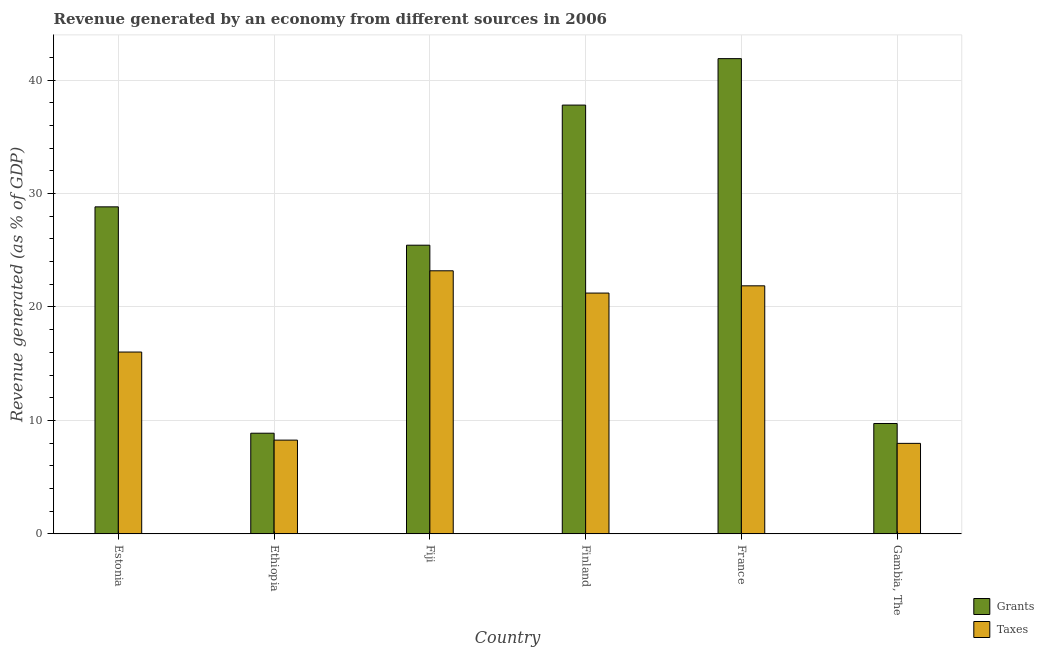How many bars are there on the 5th tick from the left?
Offer a terse response. 2. In how many cases, is the number of bars for a given country not equal to the number of legend labels?
Offer a very short reply. 0. What is the revenue generated by taxes in Ethiopia?
Provide a short and direct response. 8.26. Across all countries, what is the maximum revenue generated by grants?
Offer a terse response. 41.89. Across all countries, what is the minimum revenue generated by taxes?
Your response must be concise. 7.98. In which country was the revenue generated by taxes minimum?
Offer a terse response. Gambia, The. What is the total revenue generated by taxes in the graph?
Ensure brevity in your answer.  98.54. What is the difference between the revenue generated by grants in Ethiopia and that in Finland?
Offer a terse response. -28.92. What is the difference between the revenue generated by taxes in Gambia, The and the revenue generated by grants in France?
Your answer should be very brief. -33.91. What is the average revenue generated by grants per country?
Provide a short and direct response. 25.42. What is the difference between the revenue generated by taxes and revenue generated by grants in Finland?
Make the answer very short. -16.57. What is the ratio of the revenue generated by taxes in Estonia to that in Finland?
Ensure brevity in your answer.  0.76. Is the difference between the revenue generated by taxes in Fiji and Gambia, The greater than the difference between the revenue generated by grants in Fiji and Gambia, The?
Give a very brief answer. No. What is the difference between the highest and the second highest revenue generated by taxes?
Ensure brevity in your answer.  1.32. What is the difference between the highest and the lowest revenue generated by grants?
Your response must be concise. 33.02. In how many countries, is the revenue generated by grants greater than the average revenue generated by grants taken over all countries?
Offer a terse response. 4. Is the sum of the revenue generated by taxes in Ethiopia and Finland greater than the maximum revenue generated by grants across all countries?
Provide a short and direct response. No. What does the 1st bar from the left in Ethiopia represents?
Ensure brevity in your answer.  Grants. What does the 2nd bar from the right in Ethiopia represents?
Provide a succinct answer. Grants. Are all the bars in the graph horizontal?
Provide a short and direct response. No. How many countries are there in the graph?
Offer a terse response. 6. What is the difference between two consecutive major ticks on the Y-axis?
Your answer should be compact. 10. Are the values on the major ticks of Y-axis written in scientific E-notation?
Keep it short and to the point. No. Does the graph contain grids?
Offer a very short reply. Yes. How many legend labels are there?
Give a very brief answer. 2. How are the legend labels stacked?
Offer a very short reply. Vertical. What is the title of the graph?
Offer a terse response. Revenue generated by an economy from different sources in 2006. What is the label or title of the X-axis?
Your response must be concise. Country. What is the label or title of the Y-axis?
Provide a short and direct response. Revenue generated (as % of GDP). What is the Revenue generated (as % of GDP) of Grants in Estonia?
Provide a short and direct response. 28.82. What is the Revenue generated (as % of GDP) in Taxes in Estonia?
Your response must be concise. 16.03. What is the Revenue generated (as % of GDP) in Grants in Ethiopia?
Offer a very short reply. 8.87. What is the Revenue generated (as % of GDP) of Taxes in Ethiopia?
Your response must be concise. 8.26. What is the Revenue generated (as % of GDP) in Grants in Fiji?
Give a very brief answer. 25.44. What is the Revenue generated (as % of GDP) of Taxes in Fiji?
Your answer should be compact. 23.19. What is the Revenue generated (as % of GDP) of Grants in Finland?
Ensure brevity in your answer.  37.79. What is the Revenue generated (as % of GDP) of Taxes in Finland?
Your answer should be compact. 21.22. What is the Revenue generated (as % of GDP) of Grants in France?
Give a very brief answer. 41.89. What is the Revenue generated (as % of GDP) of Taxes in France?
Keep it short and to the point. 21.86. What is the Revenue generated (as % of GDP) in Grants in Gambia, The?
Your answer should be very brief. 9.73. What is the Revenue generated (as % of GDP) in Taxes in Gambia, The?
Offer a very short reply. 7.98. Across all countries, what is the maximum Revenue generated (as % of GDP) in Grants?
Your response must be concise. 41.89. Across all countries, what is the maximum Revenue generated (as % of GDP) in Taxes?
Your answer should be compact. 23.19. Across all countries, what is the minimum Revenue generated (as % of GDP) in Grants?
Ensure brevity in your answer.  8.87. Across all countries, what is the minimum Revenue generated (as % of GDP) of Taxes?
Make the answer very short. 7.98. What is the total Revenue generated (as % of GDP) in Grants in the graph?
Provide a succinct answer. 152.55. What is the total Revenue generated (as % of GDP) in Taxes in the graph?
Ensure brevity in your answer.  98.54. What is the difference between the Revenue generated (as % of GDP) in Grants in Estonia and that in Ethiopia?
Offer a terse response. 19.95. What is the difference between the Revenue generated (as % of GDP) in Taxes in Estonia and that in Ethiopia?
Provide a short and direct response. 7.76. What is the difference between the Revenue generated (as % of GDP) in Grants in Estonia and that in Fiji?
Ensure brevity in your answer.  3.38. What is the difference between the Revenue generated (as % of GDP) in Taxes in Estonia and that in Fiji?
Provide a succinct answer. -7.16. What is the difference between the Revenue generated (as % of GDP) of Grants in Estonia and that in Finland?
Give a very brief answer. -8.97. What is the difference between the Revenue generated (as % of GDP) in Taxes in Estonia and that in Finland?
Your answer should be very brief. -5.2. What is the difference between the Revenue generated (as % of GDP) in Grants in Estonia and that in France?
Make the answer very short. -13.06. What is the difference between the Revenue generated (as % of GDP) of Taxes in Estonia and that in France?
Ensure brevity in your answer.  -5.84. What is the difference between the Revenue generated (as % of GDP) of Grants in Estonia and that in Gambia, The?
Offer a terse response. 19.1. What is the difference between the Revenue generated (as % of GDP) in Taxes in Estonia and that in Gambia, The?
Ensure brevity in your answer.  8.05. What is the difference between the Revenue generated (as % of GDP) of Grants in Ethiopia and that in Fiji?
Offer a terse response. -16.57. What is the difference between the Revenue generated (as % of GDP) of Taxes in Ethiopia and that in Fiji?
Your answer should be compact. -14.92. What is the difference between the Revenue generated (as % of GDP) in Grants in Ethiopia and that in Finland?
Offer a terse response. -28.92. What is the difference between the Revenue generated (as % of GDP) of Taxes in Ethiopia and that in Finland?
Offer a terse response. -12.96. What is the difference between the Revenue generated (as % of GDP) of Grants in Ethiopia and that in France?
Offer a very short reply. -33.02. What is the difference between the Revenue generated (as % of GDP) of Taxes in Ethiopia and that in France?
Keep it short and to the point. -13.6. What is the difference between the Revenue generated (as % of GDP) in Grants in Ethiopia and that in Gambia, The?
Ensure brevity in your answer.  -0.86. What is the difference between the Revenue generated (as % of GDP) in Taxes in Ethiopia and that in Gambia, The?
Give a very brief answer. 0.29. What is the difference between the Revenue generated (as % of GDP) of Grants in Fiji and that in Finland?
Make the answer very short. -12.35. What is the difference between the Revenue generated (as % of GDP) of Taxes in Fiji and that in Finland?
Your answer should be very brief. 1.96. What is the difference between the Revenue generated (as % of GDP) of Grants in Fiji and that in France?
Provide a succinct answer. -16.44. What is the difference between the Revenue generated (as % of GDP) in Taxes in Fiji and that in France?
Your response must be concise. 1.32. What is the difference between the Revenue generated (as % of GDP) in Grants in Fiji and that in Gambia, The?
Keep it short and to the point. 15.72. What is the difference between the Revenue generated (as % of GDP) of Taxes in Fiji and that in Gambia, The?
Make the answer very short. 15.21. What is the difference between the Revenue generated (as % of GDP) of Grants in Finland and that in France?
Your answer should be very brief. -4.09. What is the difference between the Revenue generated (as % of GDP) in Taxes in Finland and that in France?
Your response must be concise. -0.64. What is the difference between the Revenue generated (as % of GDP) in Grants in Finland and that in Gambia, The?
Offer a terse response. 28.06. What is the difference between the Revenue generated (as % of GDP) in Taxes in Finland and that in Gambia, The?
Offer a terse response. 13.25. What is the difference between the Revenue generated (as % of GDP) of Grants in France and that in Gambia, The?
Provide a short and direct response. 32.16. What is the difference between the Revenue generated (as % of GDP) of Taxes in France and that in Gambia, The?
Give a very brief answer. 13.89. What is the difference between the Revenue generated (as % of GDP) in Grants in Estonia and the Revenue generated (as % of GDP) in Taxes in Ethiopia?
Your response must be concise. 20.56. What is the difference between the Revenue generated (as % of GDP) of Grants in Estonia and the Revenue generated (as % of GDP) of Taxes in Fiji?
Offer a terse response. 5.64. What is the difference between the Revenue generated (as % of GDP) of Grants in Estonia and the Revenue generated (as % of GDP) of Taxes in Finland?
Offer a terse response. 7.6. What is the difference between the Revenue generated (as % of GDP) in Grants in Estonia and the Revenue generated (as % of GDP) in Taxes in France?
Make the answer very short. 6.96. What is the difference between the Revenue generated (as % of GDP) of Grants in Estonia and the Revenue generated (as % of GDP) of Taxes in Gambia, The?
Your response must be concise. 20.85. What is the difference between the Revenue generated (as % of GDP) in Grants in Ethiopia and the Revenue generated (as % of GDP) in Taxes in Fiji?
Make the answer very short. -14.32. What is the difference between the Revenue generated (as % of GDP) of Grants in Ethiopia and the Revenue generated (as % of GDP) of Taxes in Finland?
Offer a terse response. -12.35. What is the difference between the Revenue generated (as % of GDP) of Grants in Ethiopia and the Revenue generated (as % of GDP) of Taxes in France?
Your answer should be compact. -12.99. What is the difference between the Revenue generated (as % of GDP) in Grants in Ethiopia and the Revenue generated (as % of GDP) in Taxes in Gambia, The?
Your response must be concise. 0.9. What is the difference between the Revenue generated (as % of GDP) of Grants in Fiji and the Revenue generated (as % of GDP) of Taxes in Finland?
Give a very brief answer. 4.22. What is the difference between the Revenue generated (as % of GDP) in Grants in Fiji and the Revenue generated (as % of GDP) in Taxes in France?
Offer a terse response. 3.58. What is the difference between the Revenue generated (as % of GDP) in Grants in Fiji and the Revenue generated (as % of GDP) in Taxes in Gambia, The?
Offer a terse response. 17.47. What is the difference between the Revenue generated (as % of GDP) of Grants in Finland and the Revenue generated (as % of GDP) of Taxes in France?
Give a very brief answer. 15.93. What is the difference between the Revenue generated (as % of GDP) in Grants in Finland and the Revenue generated (as % of GDP) in Taxes in Gambia, The?
Offer a terse response. 29.82. What is the difference between the Revenue generated (as % of GDP) in Grants in France and the Revenue generated (as % of GDP) in Taxes in Gambia, The?
Keep it short and to the point. 33.91. What is the average Revenue generated (as % of GDP) of Grants per country?
Ensure brevity in your answer.  25.42. What is the average Revenue generated (as % of GDP) of Taxes per country?
Your answer should be compact. 16.42. What is the difference between the Revenue generated (as % of GDP) of Grants and Revenue generated (as % of GDP) of Taxes in Estonia?
Make the answer very short. 12.8. What is the difference between the Revenue generated (as % of GDP) in Grants and Revenue generated (as % of GDP) in Taxes in Ethiopia?
Give a very brief answer. 0.61. What is the difference between the Revenue generated (as % of GDP) in Grants and Revenue generated (as % of GDP) in Taxes in Fiji?
Your response must be concise. 2.26. What is the difference between the Revenue generated (as % of GDP) of Grants and Revenue generated (as % of GDP) of Taxes in Finland?
Your answer should be compact. 16.57. What is the difference between the Revenue generated (as % of GDP) in Grants and Revenue generated (as % of GDP) in Taxes in France?
Provide a short and direct response. 20.02. What is the difference between the Revenue generated (as % of GDP) of Grants and Revenue generated (as % of GDP) of Taxes in Gambia, The?
Your response must be concise. 1.75. What is the ratio of the Revenue generated (as % of GDP) in Grants in Estonia to that in Ethiopia?
Offer a very short reply. 3.25. What is the ratio of the Revenue generated (as % of GDP) of Taxes in Estonia to that in Ethiopia?
Keep it short and to the point. 1.94. What is the ratio of the Revenue generated (as % of GDP) in Grants in Estonia to that in Fiji?
Your answer should be compact. 1.13. What is the ratio of the Revenue generated (as % of GDP) of Taxes in Estonia to that in Fiji?
Keep it short and to the point. 0.69. What is the ratio of the Revenue generated (as % of GDP) of Grants in Estonia to that in Finland?
Ensure brevity in your answer.  0.76. What is the ratio of the Revenue generated (as % of GDP) of Taxes in Estonia to that in Finland?
Offer a terse response. 0.76. What is the ratio of the Revenue generated (as % of GDP) of Grants in Estonia to that in France?
Offer a very short reply. 0.69. What is the ratio of the Revenue generated (as % of GDP) of Taxes in Estonia to that in France?
Your answer should be compact. 0.73. What is the ratio of the Revenue generated (as % of GDP) in Grants in Estonia to that in Gambia, The?
Ensure brevity in your answer.  2.96. What is the ratio of the Revenue generated (as % of GDP) of Taxes in Estonia to that in Gambia, The?
Make the answer very short. 2.01. What is the ratio of the Revenue generated (as % of GDP) of Grants in Ethiopia to that in Fiji?
Your answer should be very brief. 0.35. What is the ratio of the Revenue generated (as % of GDP) of Taxes in Ethiopia to that in Fiji?
Give a very brief answer. 0.36. What is the ratio of the Revenue generated (as % of GDP) of Grants in Ethiopia to that in Finland?
Provide a short and direct response. 0.23. What is the ratio of the Revenue generated (as % of GDP) in Taxes in Ethiopia to that in Finland?
Offer a very short reply. 0.39. What is the ratio of the Revenue generated (as % of GDP) in Grants in Ethiopia to that in France?
Your answer should be very brief. 0.21. What is the ratio of the Revenue generated (as % of GDP) in Taxes in Ethiopia to that in France?
Provide a short and direct response. 0.38. What is the ratio of the Revenue generated (as % of GDP) of Grants in Ethiopia to that in Gambia, The?
Your answer should be very brief. 0.91. What is the ratio of the Revenue generated (as % of GDP) of Taxes in Ethiopia to that in Gambia, The?
Make the answer very short. 1.04. What is the ratio of the Revenue generated (as % of GDP) in Grants in Fiji to that in Finland?
Your answer should be compact. 0.67. What is the ratio of the Revenue generated (as % of GDP) of Taxes in Fiji to that in Finland?
Make the answer very short. 1.09. What is the ratio of the Revenue generated (as % of GDP) of Grants in Fiji to that in France?
Your answer should be very brief. 0.61. What is the ratio of the Revenue generated (as % of GDP) in Taxes in Fiji to that in France?
Ensure brevity in your answer.  1.06. What is the ratio of the Revenue generated (as % of GDP) of Grants in Fiji to that in Gambia, The?
Your answer should be very brief. 2.62. What is the ratio of the Revenue generated (as % of GDP) of Taxes in Fiji to that in Gambia, The?
Offer a very short reply. 2.91. What is the ratio of the Revenue generated (as % of GDP) in Grants in Finland to that in France?
Provide a short and direct response. 0.9. What is the ratio of the Revenue generated (as % of GDP) of Taxes in Finland to that in France?
Your answer should be very brief. 0.97. What is the ratio of the Revenue generated (as % of GDP) in Grants in Finland to that in Gambia, The?
Provide a short and direct response. 3.89. What is the ratio of the Revenue generated (as % of GDP) in Taxes in Finland to that in Gambia, The?
Keep it short and to the point. 2.66. What is the ratio of the Revenue generated (as % of GDP) in Grants in France to that in Gambia, The?
Your answer should be compact. 4.31. What is the ratio of the Revenue generated (as % of GDP) of Taxes in France to that in Gambia, The?
Provide a succinct answer. 2.74. What is the difference between the highest and the second highest Revenue generated (as % of GDP) of Grants?
Your answer should be compact. 4.09. What is the difference between the highest and the second highest Revenue generated (as % of GDP) of Taxes?
Your answer should be compact. 1.32. What is the difference between the highest and the lowest Revenue generated (as % of GDP) of Grants?
Keep it short and to the point. 33.02. What is the difference between the highest and the lowest Revenue generated (as % of GDP) of Taxes?
Provide a short and direct response. 15.21. 